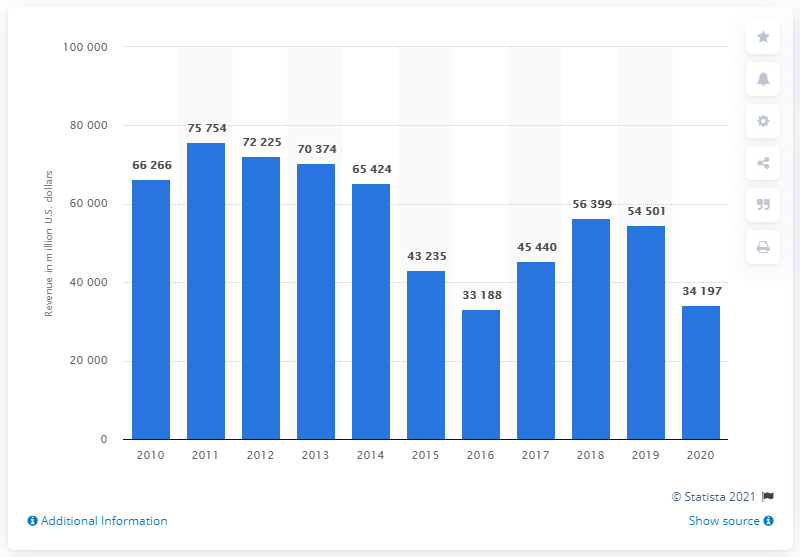List a handful of essential elements in this visual. BP's Upstream business segment generated approximately 34,197 in revenue in 2020. 